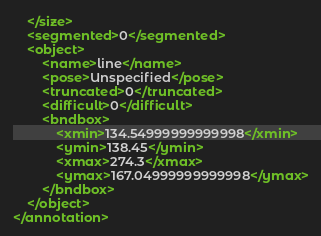<code> <loc_0><loc_0><loc_500><loc_500><_XML_>	</size>
	<segmented>0</segmented>
	<object>
		<name>line</name>
		<pose>Unspecified</pose>
		<truncated>0</truncated>
		<difficult>0</difficult>
		<bndbox>
			<xmin>134.54999999999998</xmin>
			<ymin>138.45</ymin>
			<xmax>274.3</xmax>
			<ymax>167.04999999999998</ymax>
		</bndbox>
	</object>
</annotation></code> 